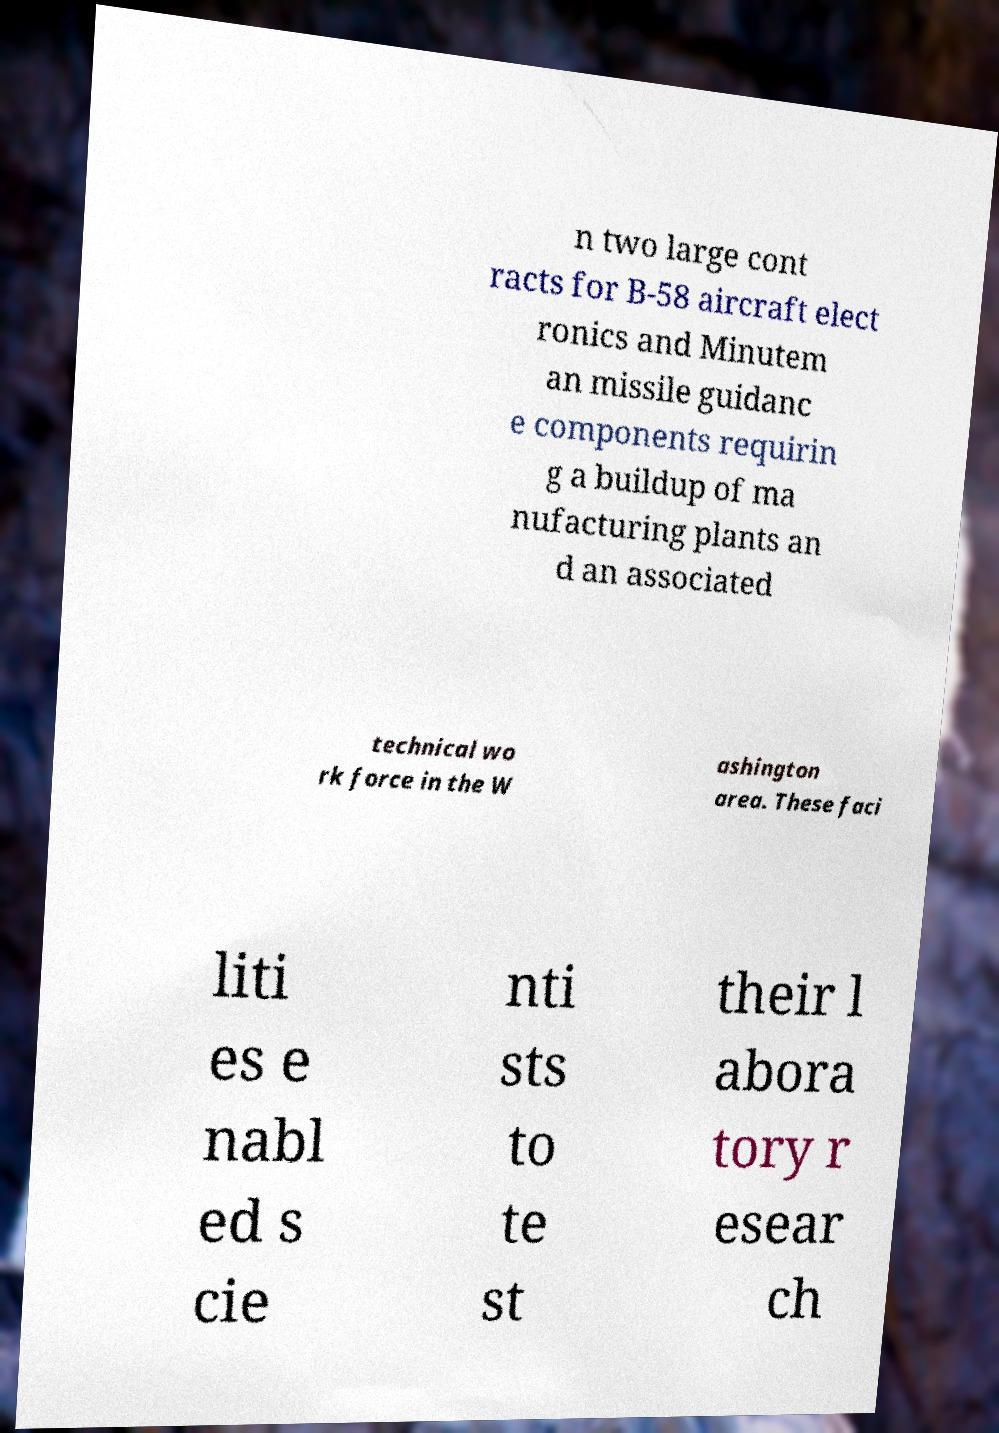There's text embedded in this image that I need extracted. Can you transcribe it verbatim? n two large cont racts for B-58 aircraft elect ronics and Minutem an missile guidanc e components requirin g a buildup of ma nufacturing plants an d an associated technical wo rk force in the W ashington area. These faci liti es e nabl ed s cie nti sts to te st their l abora tory r esear ch 